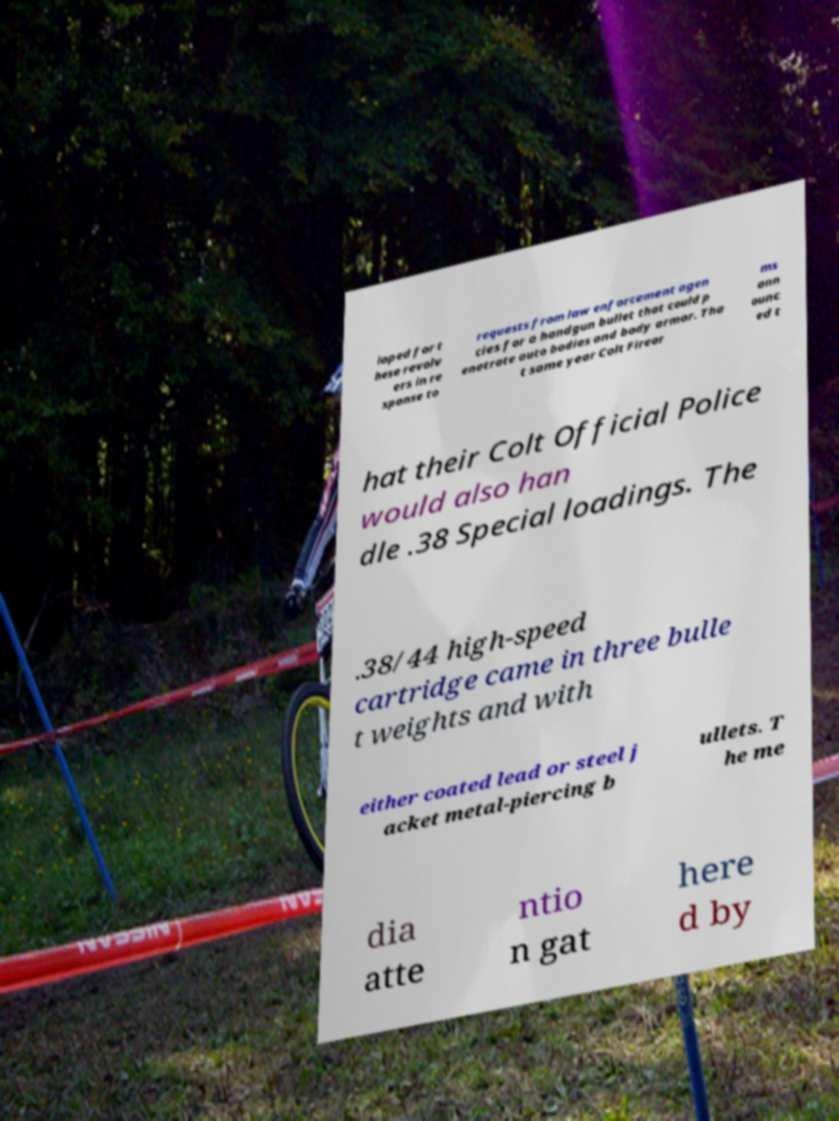Please read and relay the text visible in this image. What does it say? loped for t hese revolv ers in re sponse to requests from law enforcement agen cies for a handgun bullet that could p enetrate auto bodies and body armor. Tha t same year Colt Firear ms ann ounc ed t hat their Colt Official Police would also han dle .38 Special loadings. The .38/44 high-speed cartridge came in three bulle t weights and with either coated lead or steel j acket metal-piercing b ullets. T he me dia atte ntio n gat here d by 